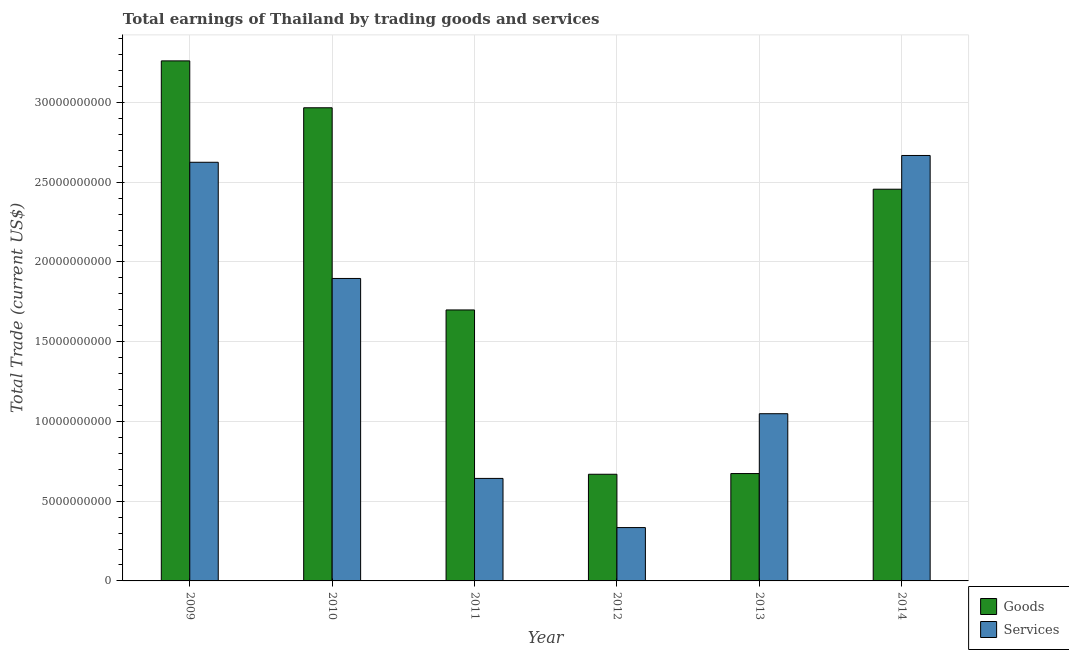How many different coloured bars are there?
Ensure brevity in your answer.  2. How many groups of bars are there?
Your answer should be compact. 6. Are the number of bars on each tick of the X-axis equal?
Offer a terse response. Yes. What is the amount earned by trading goods in 2014?
Provide a short and direct response. 2.46e+1. Across all years, what is the maximum amount earned by trading goods?
Keep it short and to the point. 3.26e+1. Across all years, what is the minimum amount earned by trading goods?
Provide a succinct answer. 6.69e+09. In which year was the amount earned by trading services minimum?
Your answer should be compact. 2012. What is the total amount earned by trading services in the graph?
Give a very brief answer. 9.21e+1. What is the difference between the amount earned by trading goods in 2010 and that in 2011?
Provide a succinct answer. 1.27e+1. What is the difference between the amount earned by trading services in 2011 and the amount earned by trading goods in 2009?
Your answer should be compact. -1.98e+1. What is the average amount earned by trading services per year?
Your response must be concise. 1.54e+1. In the year 2014, what is the difference between the amount earned by trading goods and amount earned by trading services?
Offer a very short reply. 0. What is the ratio of the amount earned by trading goods in 2011 to that in 2012?
Your answer should be compact. 2.54. Is the difference between the amount earned by trading goods in 2009 and 2013 greater than the difference between the amount earned by trading services in 2009 and 2013?
Provide a succinct answer. No. What is the difference between the highest and the second highest amount earned by trading goods?
Your response must be concise. 2.94e+09. What is the difference between the highest and the lowest amount earned by trading goods?
Give a very brief answer. 2.59e+1. Is the sum of the amount earned by trading services in 2011 and 2014 greater than the maximum amount earned by trading goods across all years?
Offer a terse response. Yes. What does the 1st bar from the left in 2009 represents?
Provide a short and direct response. Goods. What does the 1st bar from the right in 2010 represents?
Make the answer very short. Services. What is the difference between two consecutive major ticks on the Y-axis?
Provide a succinct answer. 5.00e+09. Are the values on the major ticks of Y-axis written in scientific E-notation?
Make the answer very short. No. Does the graph contain grids?
Provide a succinct answer. Yes. How are the legend labels stacked?
Provide a short and direct response. Vertical. What is the title of the graph?
Ensure brevity in your answer.  Total earnings of Thailand by trading goods and services. What is the label or title of the Y-axis?
Your answer should be compact. Total Trade (current US$). What is the Total Trade (current US$) in Goods in 2009?
Provide a succinct answer. 3.26e+1. What is the Total Trade (current US$) in Services in 2009?
Your answer should be very brief. 2.62e+1. What is the Total Trade (current US$) of Goods in 2010?
Your answer should be very brief. 2.97e+1. What is the Total Trade (current US$) of Services in 2010?
Give a very brief answer. 1.90e+1. What is the Total Trade (current US$) of Goods in 2011?
Your response must be concise. 1.70e+1. What is the Total Trade (current US$) in Services in 2011?
Offer a very short reply. 6.43e+09. What is the Total Trade (current US$) in Goods in 2012?
Offer a very short reply. 6.69e+09. What is the Total Trade (current US$) of Services in 2012?
Give a very brief answer. 3.34e+09. What is the Total Trade (current US$) of Goods in 2013?
Your response must be concise. 6.73e+09. What is the Total Trade (current US$) of Services in 2013?
Your response must be concise. 1.05e+1. What is the Total Trade (current US$) of Goods in 2014?
Give a very brief answer. 2.46e+1. What is the Total Trade (current US$) of Services in 2014?
Provide a succinct answer. 2.67e+1. Across all years, what is the maximum Total Trade (current US$) in Goods?
Make the answer very short. 3.26e+1. Across all years, what is the maximum Total Trade (current US$) in Services?
Your response must be concise. 2.67e+1. Across all years, what is the minimum Total Trade (current US$) of Goods?
Make the answer very short. 6.69e+09. Across all years, what is the minimum Total Trade (current US$) of Services?
Provide a short and direct response. 3.34e+09. What is the total Total Trade (current US$) of Goods in the graph?
Provide a succinct answer. 1.17e+11. What is the total Total Trade (current US$) of Services in the graph?
Your answer should be very brief. 9.21e+1. What is the difference between the Total Trade (current US$) in Goods in 2009 and that in 2010?
Your answer should be very brief. 2.94e+09. What is the difference between the Total Trade (current US$) of Services in 2009 and that in 2010?
Provide a succinct answer. 7.29e+09. What is the difference between the Total Trade (current US$) in Goods in 2009 and that in 2011?
Your answer should be compact. 1.56e+1. What is the difference between the Total Trade (current US$) in Services in 2009 and that in 2011?
Provide a short and direct response. 1.98e+1. What is the difference between the Total Trade (current US$) of Goods in 2009 and that in 2012?
Your answer should be very brief. 2.59e+1. What is the difference between the Total Trade (current US$) of Services in 2009 and that in 2012?
Ensure brevity in your answer.  2.29e+1. What is the difference between the Total Trade (current US$) of Goods in 2009 and that in 2013?
Offer a terse response. 2.59e+1. What is the difference between the Total Trade (current US$) in Services in 2009 and that in 2013?
Make the answer very short. 1.58e+1. What is the difference between the Total Trade (current US$) of Goods in 2009 and that in 2014?
Keep it short and to the point. 8.05e+09. What is the difference between the Total Trade (current US$) in Services in 2009 and that in 2014?
Your response must be concise. -4.27e+08. What is the difference between the Total Trade (current US$) of Goods in 2010 and that in 2011?
Your response must be concise. 1.27e+1. What is the difference between the Total Trade (current US$) of Services in 2010 and that in 2011?
Your answer should be compact. 1.25e+1. What is the difference between the Total Trade (current US$) in Goods in 2010 and that in 2012?
Offer a terse response. 2.30e+1. What is the difference between the Total Trade (current US$) of Services in 2010 and that in 2012?
Your answer should be very brief. 1.56e+1. What is the difference between the Total Trade (current US$) in Goods in 2010 and that in 2013?
Make the answer very short. 2.29e+1. What is the difference between the Total Trade (current US$) in Services in 2010 and that in 2013?
Ensure brevity in your answer.  8.48e+09. What is the difference between the Total Trade (current US$) in Goods in 2010 and that in 2014?
Offer a terse response. 5.11e+09. What is the difference between the Total Trade (current US$) of Services in 2010 and that in 2014?
Give a very brief answer. -7.71e+09. What is the difference between the Total Trade (current US$) in Goods in 2011 and that in 2012?
Provide a succinct answer. 1.03e+1. What is the difference between the Total Trade (current US$) of Services in 2011 and that in 2012?
Provide a succinct answer. 3.08e+09. What is the difference between the Total Trade (current US$) in Goods in 2011 and that in 2013?
Your response must be concise. 1.03e+1. What is the difference between the Total Trade (current US$) of Services in 2011 and that in 2013?
Keep it short and to the point. -4.06e+09. What is the difference between the Total Trade (current US$) of Goods in 2011 and that in 2014?
Make the answer very short. -7.57e+09. What is the difference between the Total Trade (current US$) of Services in 2011 and that in 2014?
Provide a short and direct response. -2.02e+1. What is the difference between the Total Trade (current US$) of Goods in 2012 and that in 2013?
Make the answer very short. -4.36e+07. What is the difference between the Total Trade (current US$) of Services in 2012 and that in 2013?
Provide a short and direct response. -7.14e+09. What is the difference between the Total Trade (current US$) in Goods in 2012 and that in 2014?
Give a very brief answer. -1.79e+1. What is the difference between the Total Trade (current US$) of Services in 2012 and that in 2014?
Keep it short and to the point. -2.33e+1. What is the difference between the Total Trade (current US$) of Goods in 2013 and that in 2014?
Offer a terse response. -1.78e+1. What is the difference between the Total Trade (current US$) of Services in 2013 and that in 2014?
Give a very brief answer. -1.62e+1. What is the difference between the Total Trade (current US$) of Goods in 2009 and the Total Trade (current US$) of Services in 2010?
Offer a very short reply. 1.36e+1. What is the difference between the Total Trade (current US$) of Goods in 2009 and the Total Trade (current US$) of Services in 2011?
Offer a very short reply. 2.62e+1. What is the difference between the Total Trade (current US$) in Goods in 2009 and the Total Trade (current US$) in Services in 2012?
Provide a short and direct response. 2.93e+1. What is the difference between the Total Trade (current US$) in Goods in 2009 and the Total Trade (current US$) in Services in 2013?
Ensure brevity in your answer.  2.21e+1. What is the difference between the Total Trade (current US$) in Goods in 2009 and the Total Trade (current US$) in Services in 2014?
Your answer should be very brief. 5.93e+09. What is the difference between the Total Trade (current US$) in Goods in 2010 and the Total Trade (current US$) in Services in 2011?
Provide a short and direct response. 2.32e+1. What is the difference between the Total Trade (current US$) in Goods in 2010 and the Total Trade (current US$) in Services in 2012?
Offer a terse response. 2.63e+1. What is the difference between the Total Trade (current US$) in Goods in 2010 and the Total Trade (current US$) in Services in 2013?
Your answer should be compact. 1.92e+1. What is the difference between the Total Trade (current US$) in Goods in 2010 and the Total Trade (current US$) in Services in 2014?
Offer a terse response. 2.99e+09. What is the difference between the Total Trade (current US$) in Goods in 2011 and the Total Trade (current US$) in Services in 2012?
Your answer should be compact. 1.36e+1. What is the difference between the Total Trade (current US$) in Goods in 2011 and the Total Trade (current US$) in Services in 2013?
Provide a succinct answer. 6.51e+09. What is the difference between the Total Trade (current US$) of Goods in 2011 and the Total Trade (current US$) of Services in 2014?
Offer a very short reply. -9.69e+09. What is the difference between the Total Trade (current US$) of Goods in 2012 and the Total Trade (current US$) of Services in 2013?
Offer a terse response. -3.80e+09. What is the difference between the Total Trade (current US$) of Goods in 2012 and the Total Trade (current US$) of Services in 2014?
Your answer should be compact. -2.00e+1. What is the difference between the Total Trade (current US$) in Goods in 2013 and the Total Trade (current US$) in Services in 2014?
Your answer should be compact. -1.99e+1. What is the average Total Trade (current US$) of Goods per year?
Offer a terse response. 1.95e+1. What is the average Total Trade (current US$) of Services per year?
Offer a very short reply. 1.54e+1. In the year 2009, what is the difference between the Total Trade (current US$) in Goods and Total Trade (current US$) in Services?
Your answer should be very brief. 6.36e+09. In the year 2010, what is the difference between the Total Trade (current US$) of Goods and Total Trade (current US$) of Services?
Your answer should be very brief. 1.07e+1. In the year 2011, what is the difference between the Total Trade (current US$) in Goods and Total Trade (current US$) in Services?
Keep it short and to the point. 1.06e+1. In the year 2012, what is the difference between the Total Trade (current US$) in Goods and Total Trade (current US$) in Services?
Offer a very short reply. 3.34e+09. In the year 2013, what is the difference between the Total Trade (current US$) in Goods and Total Trade (current US$) in Services?
Offer a very short reply. -3.75e+09. In the year 2014, what is the difference between the Total Trade (current US$) of Goods and Total Trade (current US$) of Services?
Offer a terse response. -2.12e+09. What is the ratio of the Total Trade (current US$) in Goods in 2009 to that in 2010?
Your answer should be very brief. 1.1. What is the ratio of the Total Trade (current US$) of Services in 2009 to that in 2010?
Give a very brief answer. 1.38. What is the ratio of the Total Trade (current US$) of Goods in 2009 to that in 2011?
Provide a succinct answer. 1.92. What is the ratio of the Total Trade (current US$) of Services in 2009 to that in 2011?
Give a very brief answer. 4.08. What is the ratio of the Total Trade (current US$) of Goods in 2009 to that in 2012?
Your answer should be very brief. 4.88. What is the ratio of the Total Trade (current US$) in Services in 2009 to that in 2012?
Ensure brevity in your answer.  7.85. What is the ratio of the Total Trade (current US$) in Goods in 2009 to that in 2013?
Your answer should be very brief. 4.84. What is the ratio of the Total Trade (current US$) in Services in 2009 to that in 2013?
Your answer should be compact. 2.5. What is the ratio of the Total Trade (current US$) in Goods in 2009 to that in 2014?
Ensure brevity in your answer.  1.33. What is the ratio of the Total Trade (current US$) in Goods in 2010 to that in 2011?
Provide a succinct answer. 1.75. What is the ratio of the Total Trade (current US$) in Services in 2010 to that in 2011?
Keep it short and to the point. 2.95. What is the ratio of the Total Trade (current US$) in Goods in 2010 to that in 2012?
Make the answer very short. 4.44. What is the ratio of the Total Trade (current US$) of Services in 2010 to that in 2012?
Your response must be concise. 5.67. What is the ratio of the Total Trade (current US$) in Goods in 2010 to that in 2013?
Your answer should be very brief. 4.41. What is the ratio of the Total Trade (current US$) of Services in 2010 to that in 2013?
Offer a very short reply. 1.81. What is the ratio of the Total Trade (current US$) of Goods in 2010 to that in 2014?
Ensure brevity in your answer.  1.21. What is the ratio of the Total Trade (current US$) of Services in 2010 to that in 2014?
Make the answer very short. 0.71. What is the ratio of the Total Trade (current US$) of Goods in 2011 to that in 2012?
Your answer should be very brief. 2.54. What is the ratio of the Total Trade (current US$) in Services in 2011 to that in 2012?
Provide a succinct answer. 1.92. What is the ratio of the Total Trade (current US$) of Goods in 2011 to that in 2013?
Your answer should be compact. 2.52. What is the ratio of the Total Trade (current US$) in Services in 2011 to that in 2013?
Make the answer very short. 0.61. What is the ratio of the Total Trade (current US$) of Goods in 2011 to that in 2014?
Offer a terse response. 0.69. What is the ratio of the Total Trade (current US$) in Services in 2011 to that in 2014?
Provide a short and direct response. 0.24. What is the ratio of the Total Trade (current US$) of Services in 2012 to that in 2013?
Provide a short and direct response. 0.32. What is the ratio of the Total Trade (current US$) of Goods in 2012 to that in 2014?
Your response must be concise. 0.27. What is the ratio of the Total Trade (current US$) of Services in 2012 to that in 2014?
Provide a short and direct response. 0.13. What is the ratio of the Total Trade (current US$) in Goods in 2013 to that in 2014?
Provide a succinct answer. 0.27. What is the ratio of the Total Trade (current US$) in Services in 2013 to that in 2014?
Offer a terse response. 0.39. What is the difference between the highest and the second highest Total Trade (current US$) in Goods?
Keep it short and to the point. 2.94e+09. What is the difference between the highest and the second highest Total Trade (current US$) of Services?
Give a very brief answer. 4.27e+08. What is the difference between the highest and the lowest Total Trade (current US$) of Goods?
Make the answer very short. 2.59e+1. What is the difference between the highest and the lowest Total Trade (current US$) of Services?
Provide a short and direct response. 2.33e+1. 